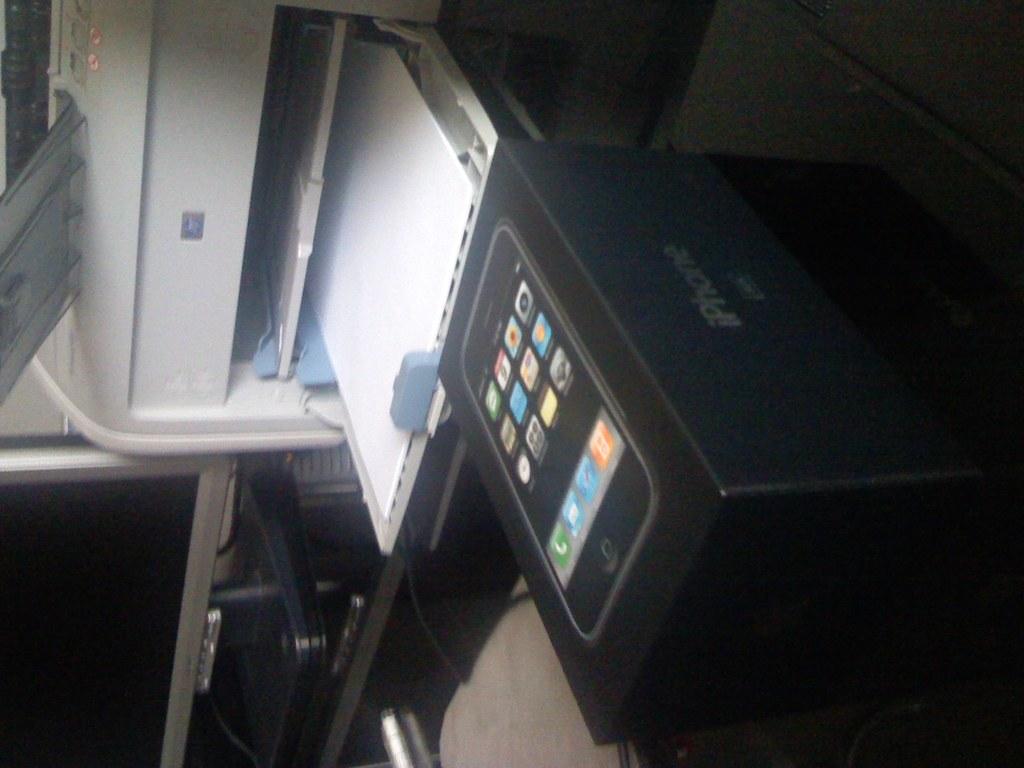What brand of phone is this box for?
Make the answer very short. Iphone. 